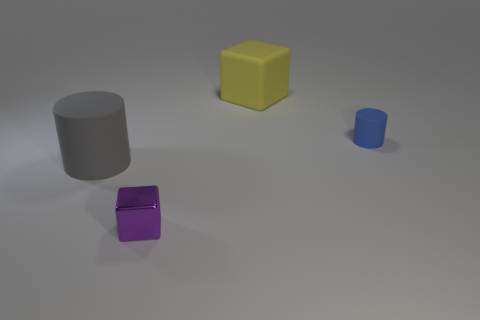There is a rubber cylinder that is behind the rubber object left of the block that is in front of the big gray cylinder; what size is it?
Offer a very short reply. Small. Are there more tiny blue objects that are behind the blue cylinder than cylinders that are to the left of the small purple metallic thing?
Give a very brief answer. No. How many gray matte cylinders are behind the block that is left of the large yellow matte cube?
Offer a very short reply. 1. Is there a shiny thing of the same color as the small matte object?
Your answer should be compact. No. Is the size of the gray cylinder the same as the purple thing?
Offer a terse response. No. Is the small rubber cylinder the same color as the big block?
Your answer should be compact. No. What material is the block left of the big matte thing that is on the right side of the purple metallic cube?
Keep it short and to the point. Metal. There is another object that is the same shape as the metallic object; what is its material?
Ensure brevity in your answer.  Rubber. There is a block that is in front of the rubber block; is it the same size as the yellow thing?
Your answer should be compact. No. What number of metallic objects are tiny cylinders or big objects?
Give a very brief answer. 0. 